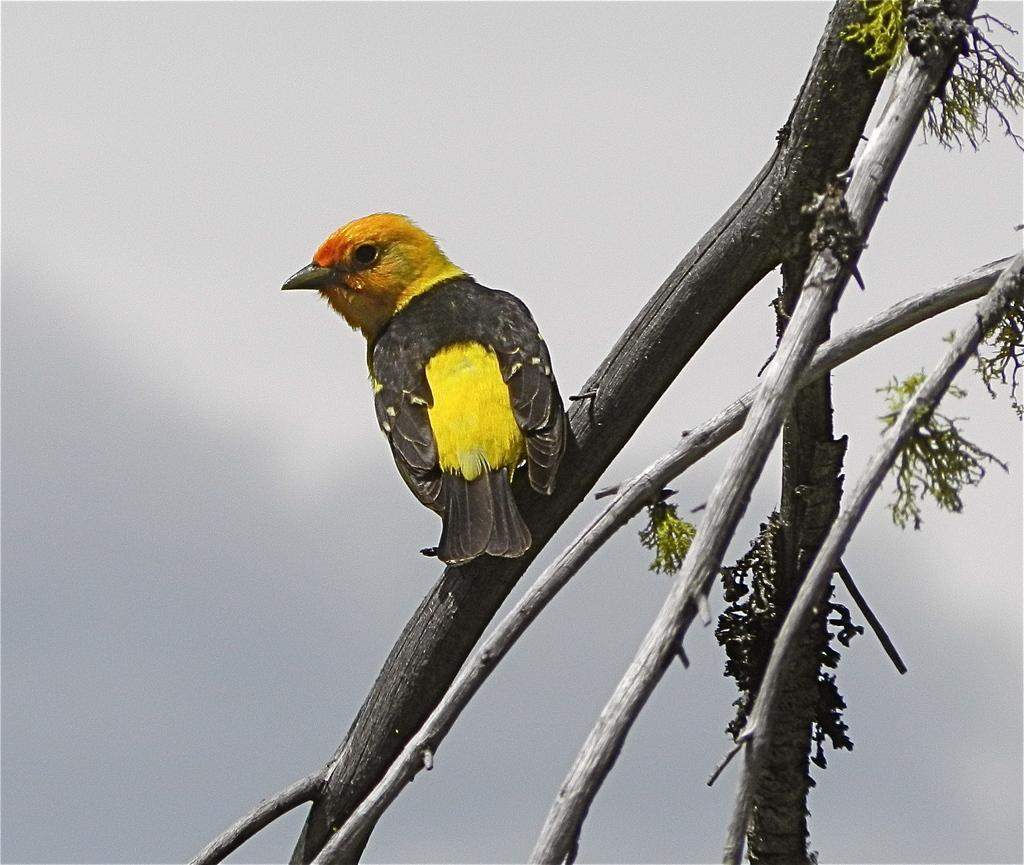What type of animal can be seen in the image? There is a bird in the image. Where is the bird located? The bird is on a branch. What is the branch connected to? The branch is from a tree. What is the condition of the tree's leaves? The tree has green leaves. What can be seen in the background of the image? There are clouds in the sky in the background of the image. What emotion does the kitten display while playing with the bird in the image? There is no kitten present in the image, and therefore no such interaction or emotion can be observed. 